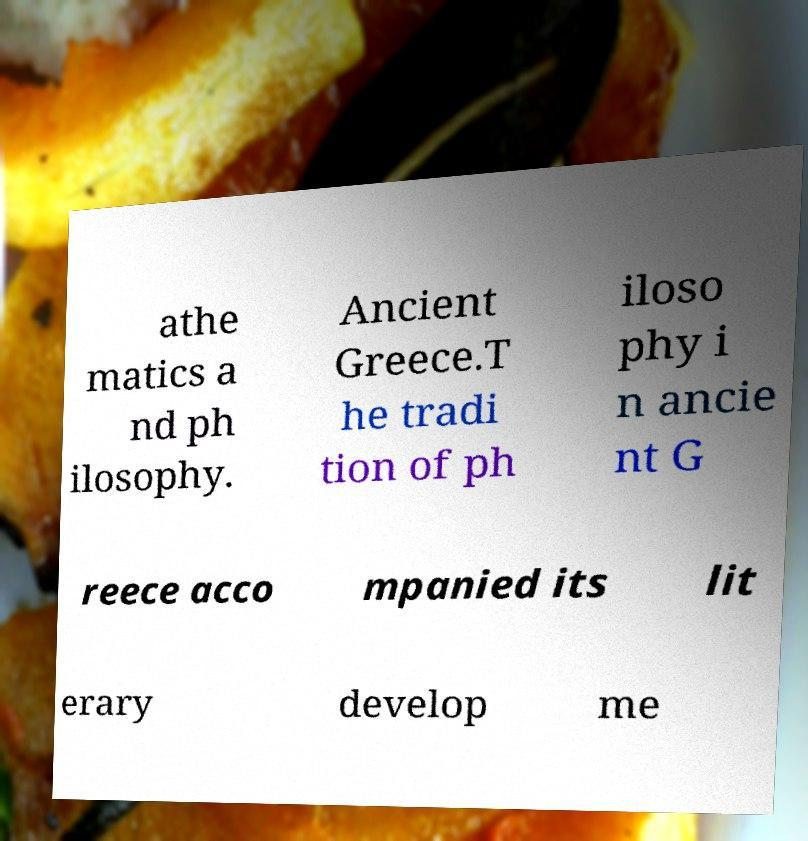For documentation purposes, I need the text within this image transcribed. Could you provide that? athe matics a nd ph ilosophy. Ancient Greece.T he tradi tion of ph iloso phy i n ancie nt G reece acco mpanied its lit erary develop me 